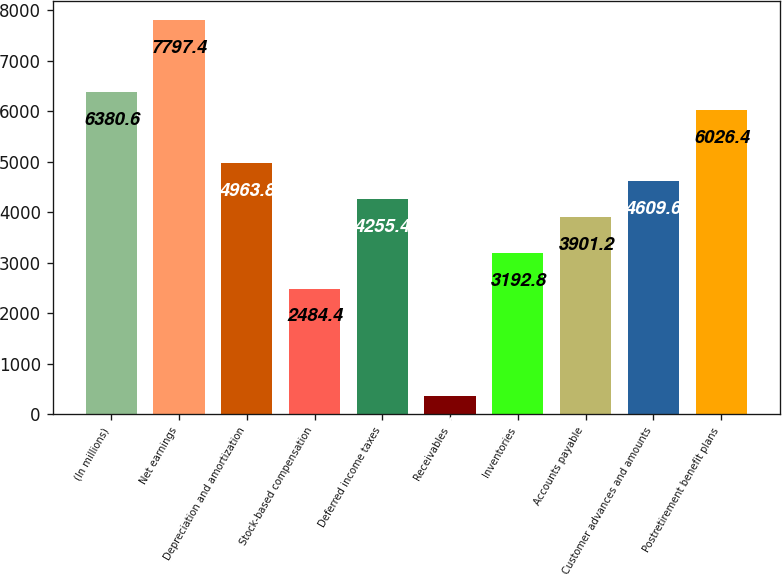Convert chart. <chart><loc_0><loc_0><loc_500><loc_500><bar_chart><fcel>(In millions)<fcel>Net earnings<fcel>Depreciation and amortization<fcel>Stock-based compensation<fcel>Deferred income taxes<fcel>Receivables<fcel>Inventories<fcel>Accounts payable<fcel>Customer advances and amounts<fcel>Postretirement benefit plans<nl><fcel>6380.6<fcel>7797.4<fcel>4963.8<fcel>2484.4<fcel>4255.4<fcel>359.2<fcel>3192.8<fcel>3901.2<fcel>4609.6<fcel>6026.4<nl></chart> 